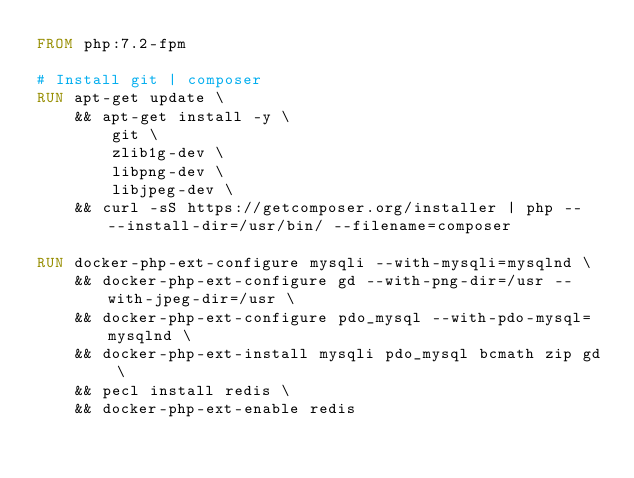<code> <loc_0><loc_0><loc_500><loc_500><_Dockerfile_>FROM php:7.2-fpm

# Install git | composer
RUN apt-get update \
    && apt-get install -y \ 
        git \
        zlib1g-dev \
        libpng-dev \
        libjpeg-dev \
    && curl -sS https://getcomposer.org/installer | php -- --install-dir=/usr/bin/ --filename=composer

RUN docker-php-ext-configure mysqli --with-mysqli=mysqlnd \
    && docker-php-ext-configure gd --with-png-dir=/usr --with-jpeg-dir=/usr \
    && docker-php-ext-configure pdo_mysql --with-pdo-mysql=mysqlnd \
    && docker-php-ext-install mysqli pdo_mysql bcmath zip gd \
    && pecl install redis \
    && docker-php-ext-enable redis
</code> 